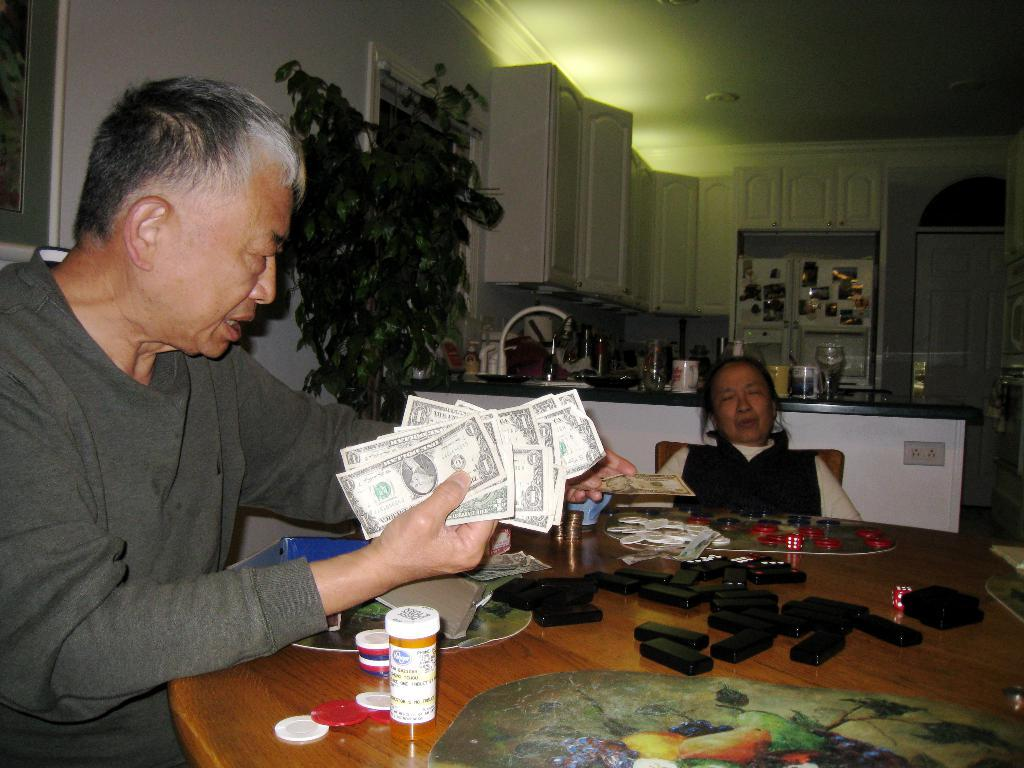What is the person in the image wearing? The person in the image is wearing a grey shirt. What is the person holding in their hands? The person is holding money in their hands. Who is sitting beside the person? There is a woman sitting beside the person. What is in front of the person and the woman? There is a table in front of them. What can be seen on the table? There are objects on the table. What type of authority does the person in the image have over the organization? There is no mention of an organization or authority in the image, so this question cannot be answered definitively. 